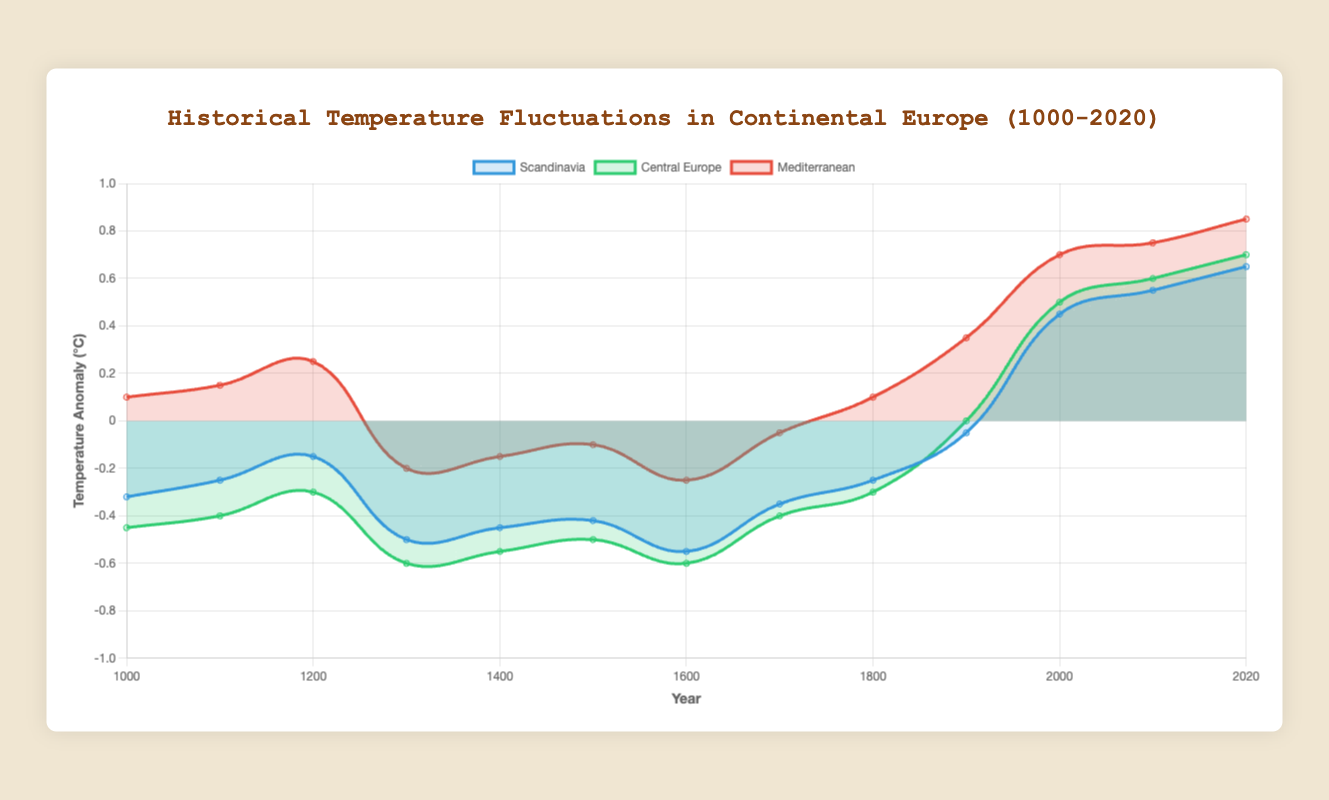What year did the temperature in Scandinavia first go above 0°C? To find when the temperature in Scandinavia first surpassed 0°C, visually follow the line for Scandinavia until it crosses the 0°C line. This first happens around the year 2000.
Answer: 2000 Which region had the highest temperature anomaly in the year 1300? To determine the highest temperature anomaly in 1300, compare the data points for Scandinavia, Central Europe, and the Mediterranean in 1300. The Mediterranean had a temperature anomaly of -0.20, which is the highest among the three regions.
Answer: Mediterranean Which decade shows the highest overall temperatures for all three regions? Visually scan all the lines and focus on the higher segments. The highest overall temperatures for Scandinavia, Central Europe, and the Mediterranean occur around the 2010s and 2020s. The 2020s show the highest temperature anomalies for all three regions: 0.65 (Scandinavia), 0.70 (Central Europe), and 0.85 (Mediterranean).
Answer: 2020s In what century did Central Europe experience its lowest temperature anomaly? To find the century with the lowest temperature anomaly for Central Europe, visually track the line for Central Europe and identify the lowest point, which occurs in the 1300s (-0.60).
Answer: 13th century What was the difference in temperature anomalies between Scandinavia and the Mediterranean in the year 1000? For the year 1000, the temperature anomaly for Scandinavia is -0.32 while for the Mediterranean it is 0.10. The difference is calculated by subtracting (-0.32) from 0.10, which equals 0.42°C.
Answer: 0.42°C How did the temperature anomaly in Central Europe change from the year 1900 to the year 2000? In 1900, Central Europe had a temperature anomaly of 0.00°C, and in 2000, it was 0.50°C. The change is calculated by subtracting 0.00 from 0.50, which results in an increase of 0.50°C.
Answer: Increased by 0.50°C Which region had the most stable temperature anomalies over the millennium, and how can you tell? To determine the most stable region, observe the lines for each region and identify the one with the least variation in the temperature anomalies. Central Europe shows relatively moderate fluctuations compared to Scandinavia and the Mediterranean, indicating it has the most stable temperature anomalies.
Answer: Central Europe On average, how did Mediterranean temperatures in the 1100s compare to those in the 1200s? For the 1100s, the Mediterranean temperature anomaly is 0.15°C, and for the 1200s, it is 0.25°C. The average temperature increase is calculated by subtracting 0.15 from 0.25, resulting in 0.10°C.
Answer: Increased by 0.10°C What is the trend observed in Scandinavian temperature anomalies from 1600 to 2020? Visually track the Scandinavian line from 1600 (-0.55) to 2020 (0.65). There's an upward trend, showing an overall increase.
Answer: Upward trend What color represents Central Europe in the chart, and how can you identify it? To identify the color representing Central Europe, observe the legend which matches regions to colors. Central Europe is indicated by green.
Answer: Green 